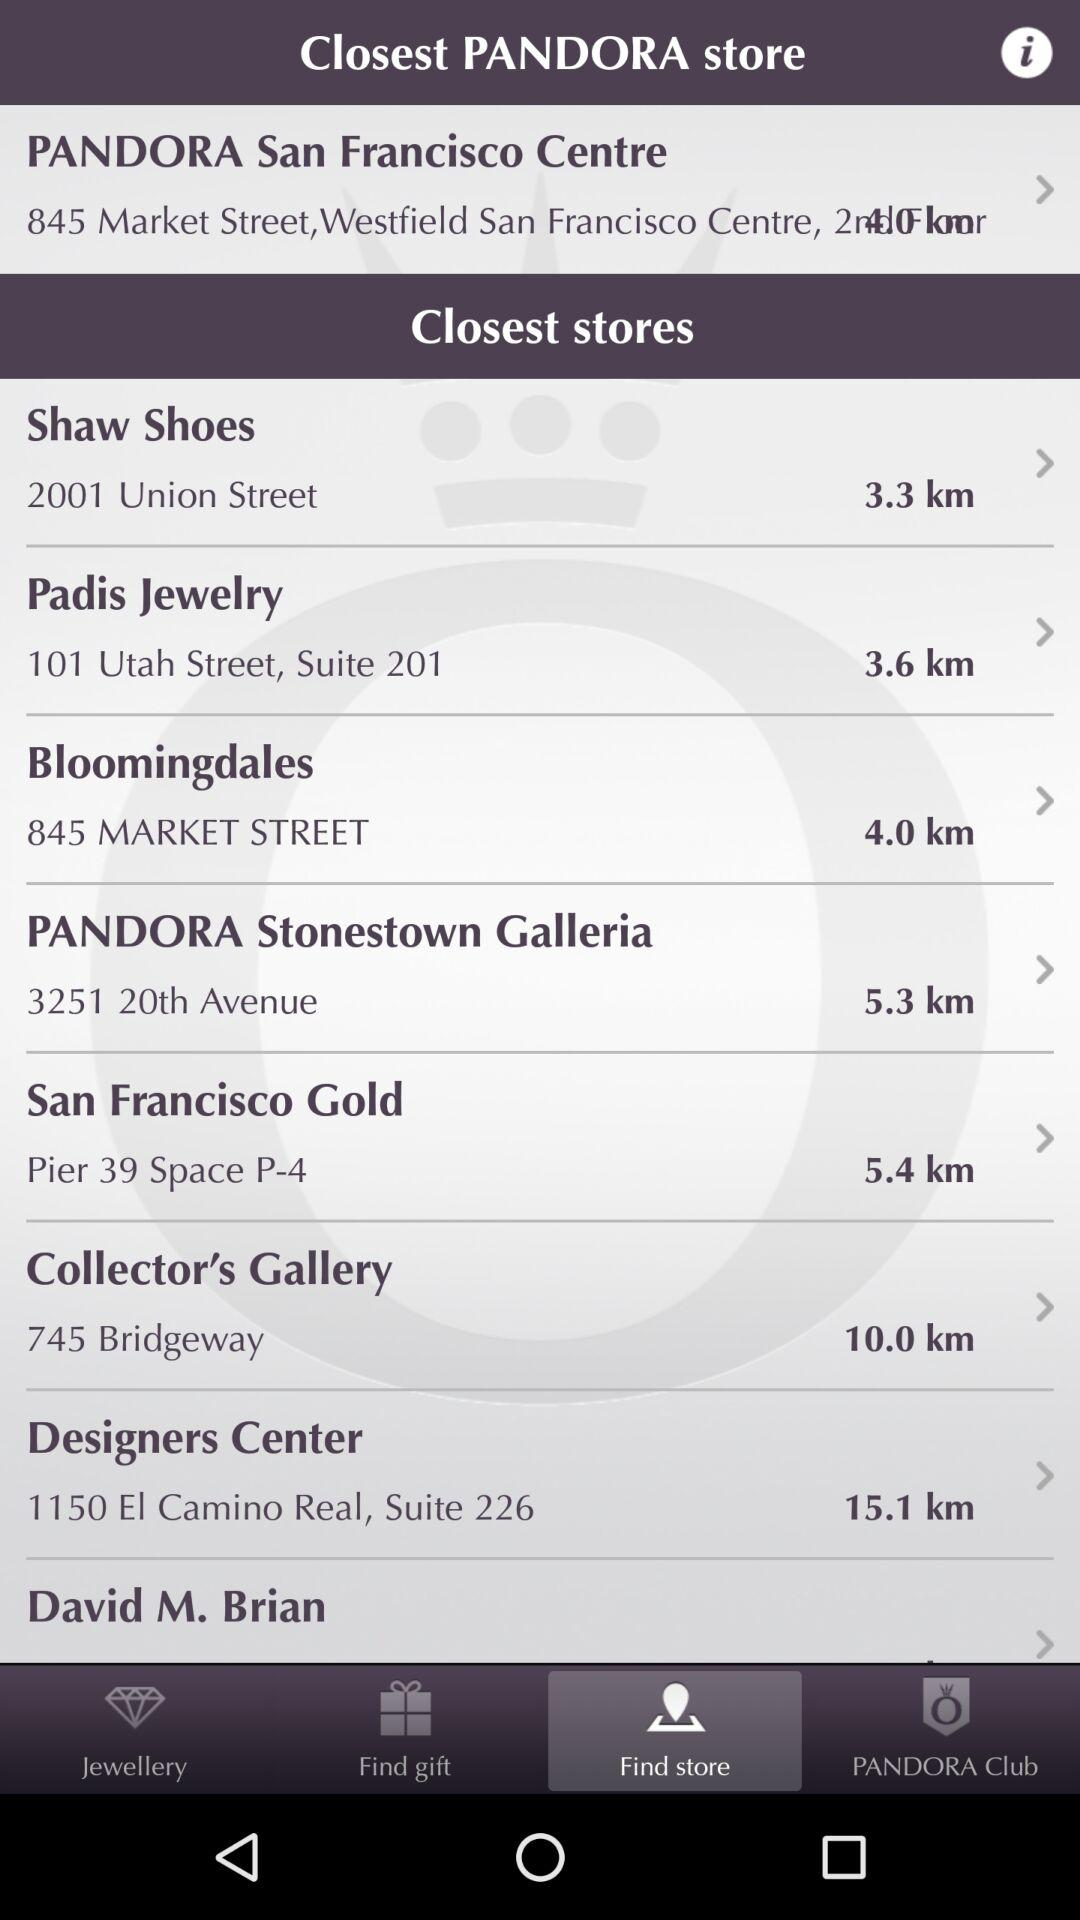What is the "Bloomingdales" location? The location is 845 Market Street. 